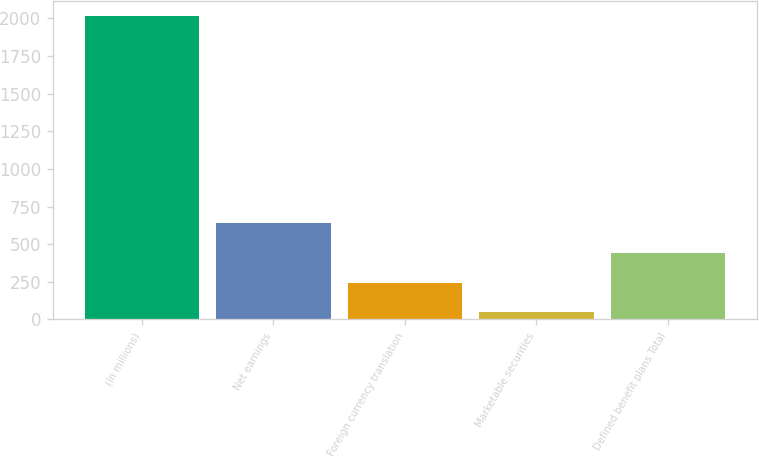Convert chart. <chart><loc_0><loc_0><loc_500><loc_500><bar_chart><fcel>(In millions)<fcel>Net earnings<fcel>Foreign currency translation<fcel>Marketable securities<fcel>Defined benefit plans Total<nl><fcel>2015<fcel>637.4<fcel>243.8<fcel>47<fcel>440.6<nl></chart> 